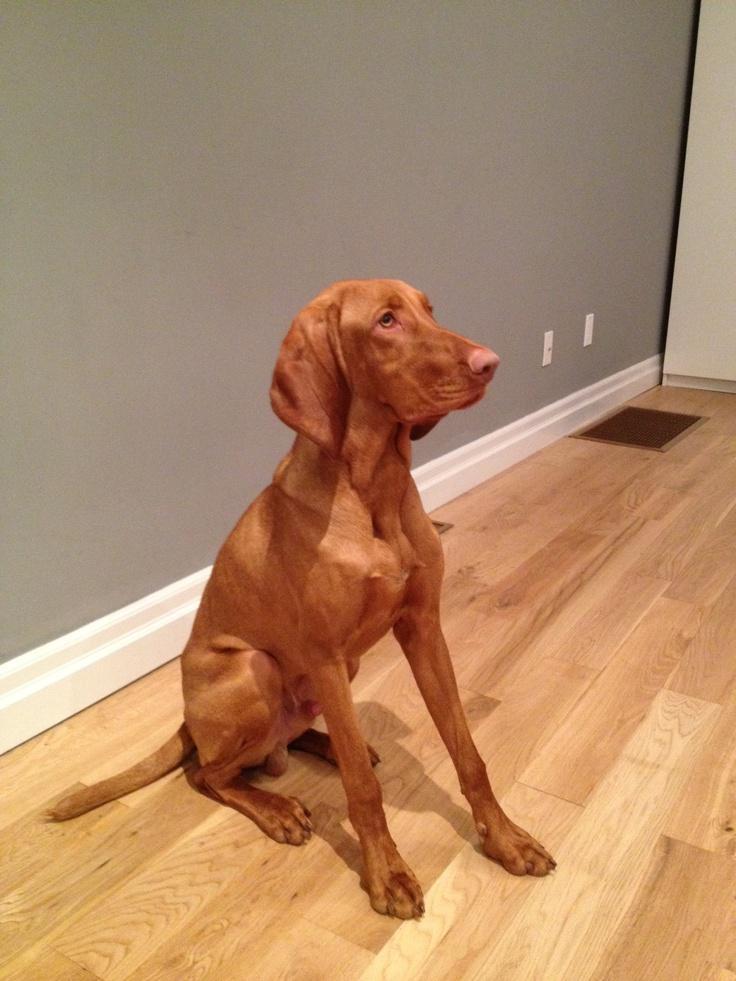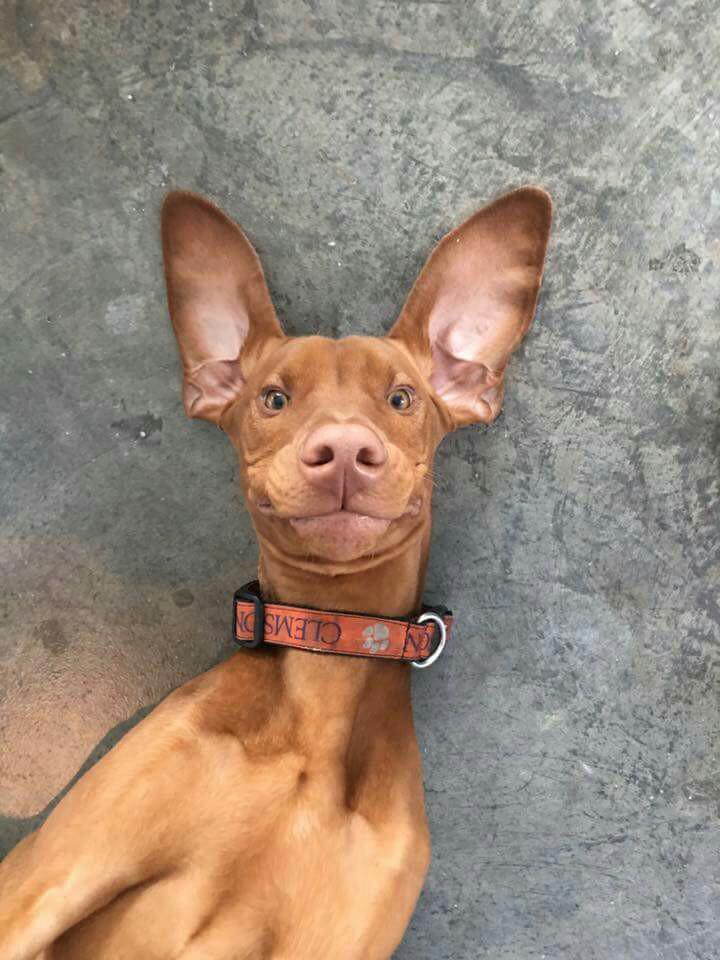The first image is the image on the left, the second image is the image on the right. Examine the images to the left and right. Is the description "Each image includes a red-orange dog with floppy ears in an upright sitting position, the dog depicted in the left image is facing forward, and a dog depicted in the right image has something on top of its muzzle." accurate? Answer yes or no. No. 